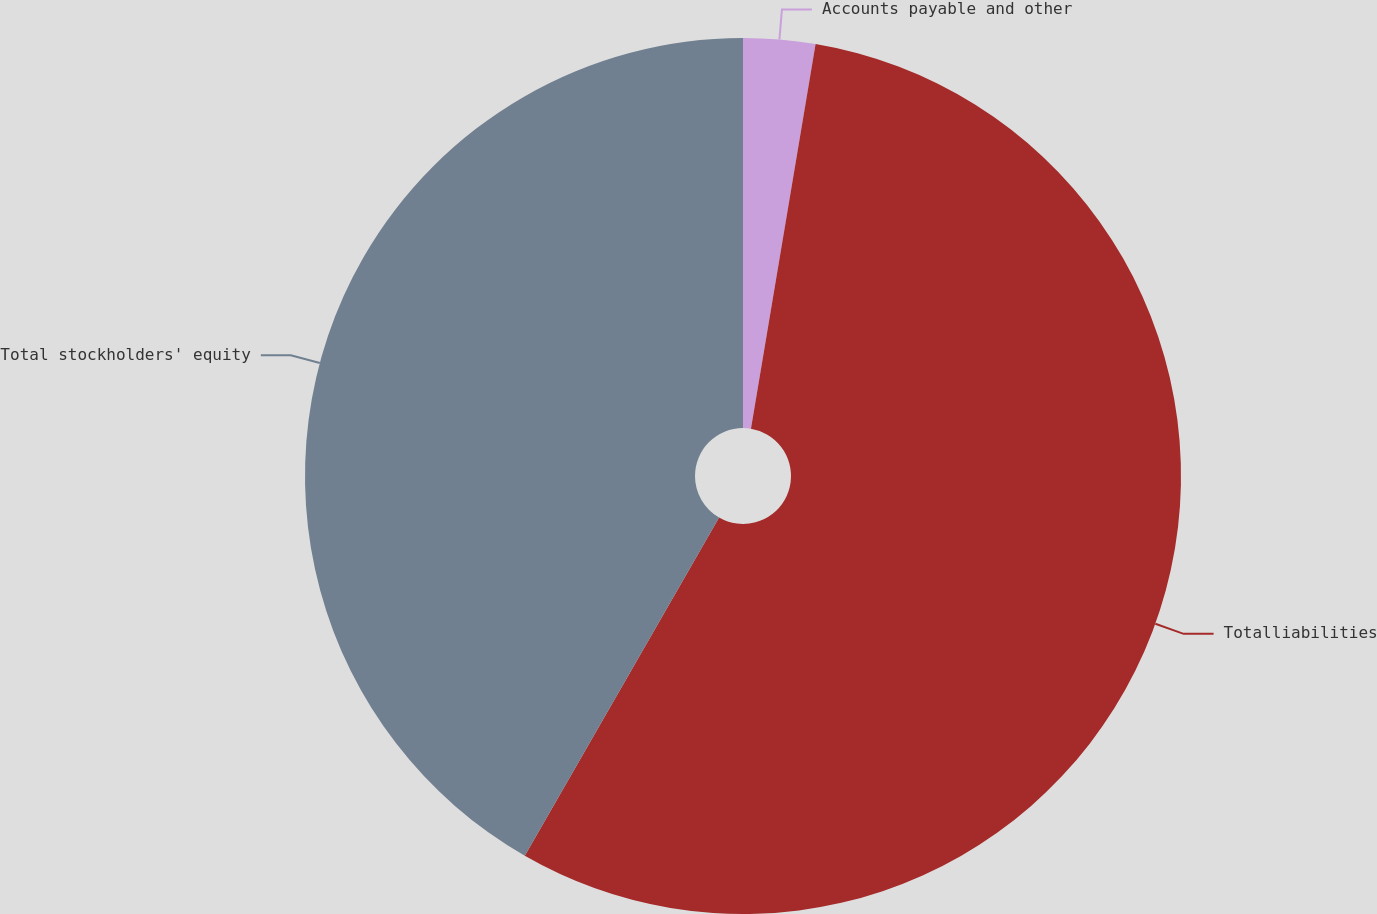Convert chart to OTSL. <chart><loc_0><loc_0><loc_500><loc_500><pie_chart><fcel>Accounts payable and other<fcel>Totalliabilities<fcel>Total stockholders' equity<nl><fcel>2.65%<fcel>55.65%<fcel>41.7%<nl></chart> 